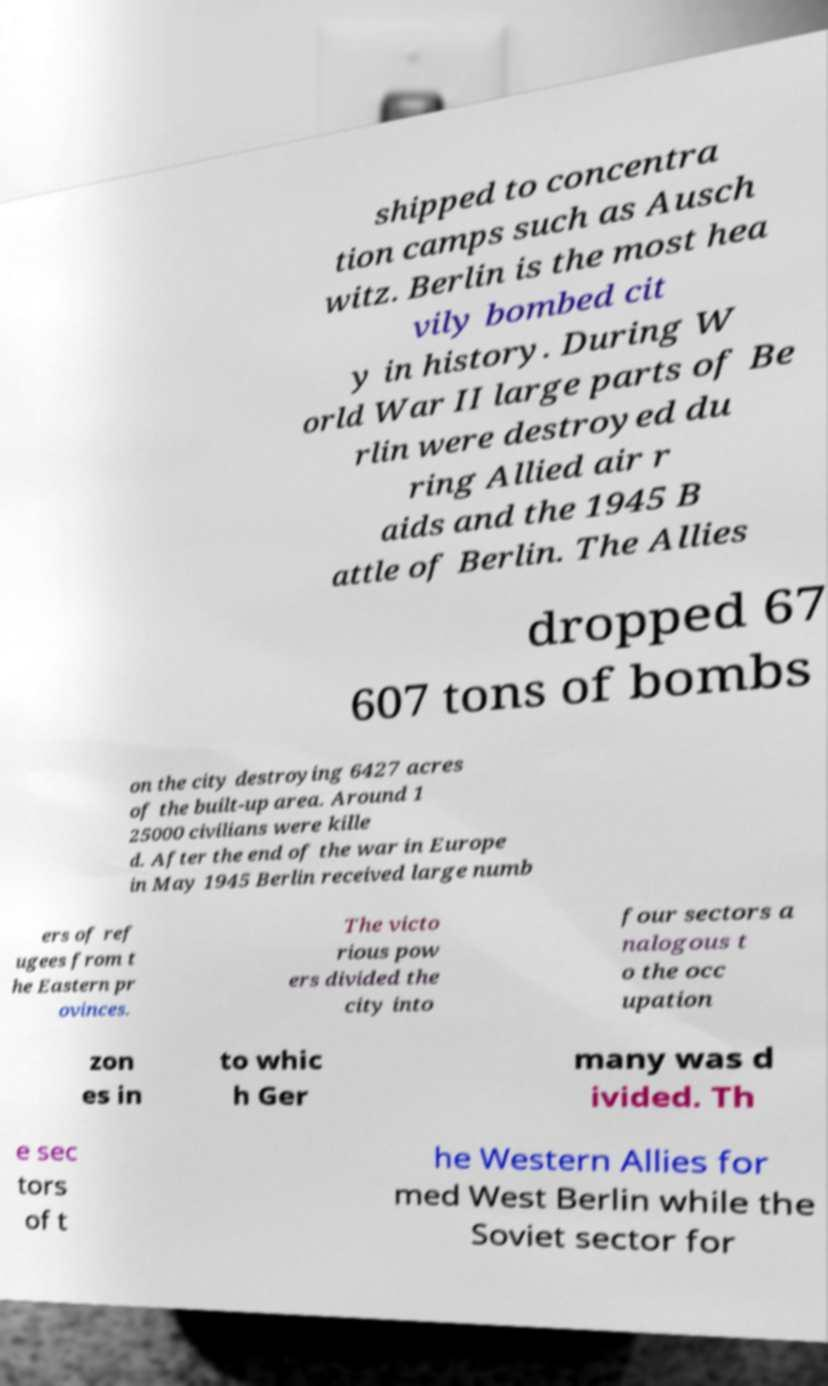Can you read and provide the text displayed in the image?This photo seems to have some interesting text. Can you extract and type it out for me? shipped to concentra tion camps such as Ausch witz. Berlin is the most hea vily bombed cit y in history. During W orld War II large parts of Be rlin were destroyed du ring Allied air r aids and the 1945 B attle of Berlin. The Allies dropped 67 607 tons of bombs on the city destroying 6427 acres of the built-up area. Around 1 25000 civilians were kille d. After the end of the war in Europe in May 1945 Berlin received large numb ers of ref ugees from t he Eastern pr ovinces. The victo rious pow ers divided the city into four sectors a nalogous t o the occ upation zon es in to whic h Ger many was d ivided. Th e sec tors of t he Western Allies for med West Berlin while the Soviet sector for 